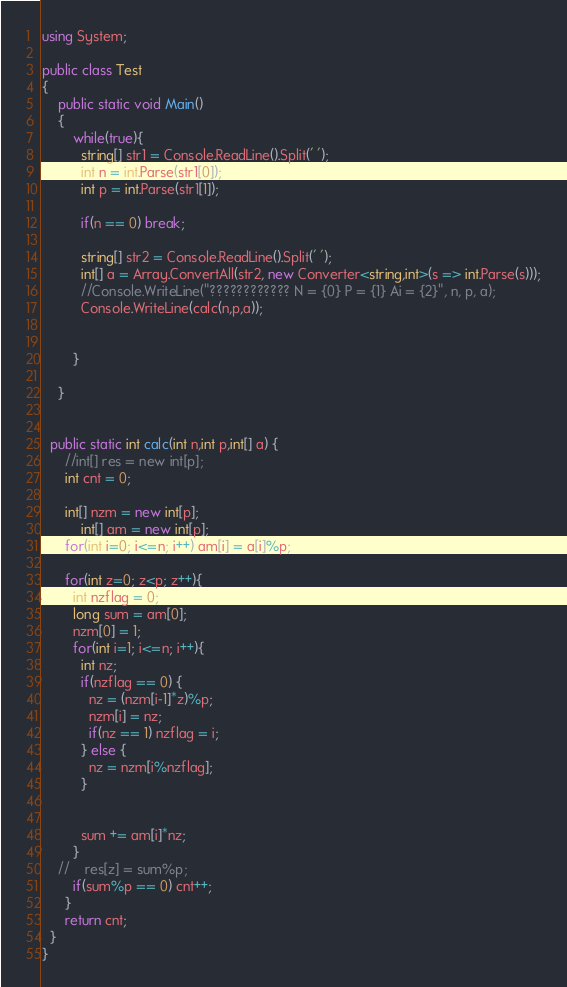<code> <loc_0><loc_0><loc_500><loc_500><_C#_>using System;

public class Test
{
	public static void Main()
	{
		while(true){
		  string[] str1 = Console.ReadLine().Split(' ');
		  int n = int.Parse(str1[0]); 
		  int p = int.Parse(str1[1]); 

		  if(n == 0) break;
		
		  string[] str2 = Console.ReadLine().Split(' ');
		  int[] a = Array.ConvertAll(str2, new Converter<string,int>(s => int.Parse(s)));
		  //Console.WriteLine("???????????? N = {0} P = {1} Ai = {2}", n, p, a);
		  Console.WriteLine(calc(n,p,a));
		
		
		}

	}

  
  public static int calc(int n,int p,int[] a) {
	  //int[] res = new int[p];
	  int cnt = 0;
	
	  int[] nzm = new int[p];
          int[] am = new int[p];
	  for(int i=0; i<=n; i++) am[i] = a[i]%p;	

	  for(int z=0; z<p; z++){
	    int nzflag = 0;
	    long sum = am[0];
	    nzm[0] = 1;
	    for(int i=1; i<=n; i++){
	      int nz;
	      if(nzflag == 0) {
	        nz = (nzm[i-1]*z)%p;
	        nzm[i] = nz;
	        if(nz == 1) nzflag = i;
	      } else {
	        nz = nzm[i%nzflag];	
	      }
	    	
	    	
	      sum += am[i]*nz;
	    }
	//    res[z] = sum%p;
	    if(sum%p == 0) cnt++;
	  }
	  return cnt;
  }
}</code> 